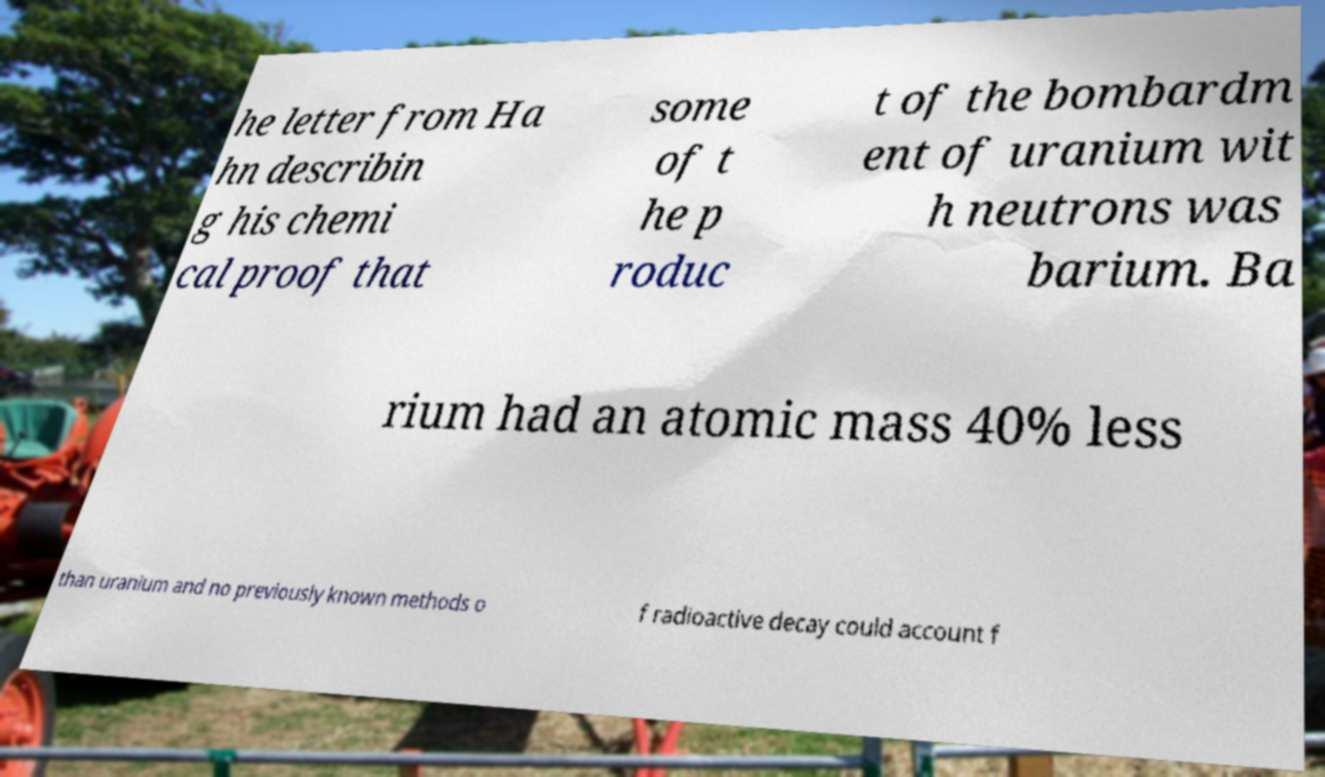Please read and relay the text visible in this image. What does it say? he letter from Ha hn describin g his chemi cal proof that some of t he p roduc t of the bombardm ent of uranium wit h neutrons was barium. Ba rium had an atomic mass 40% less than uranium and no previously known methods o f radioactive decay could account f 